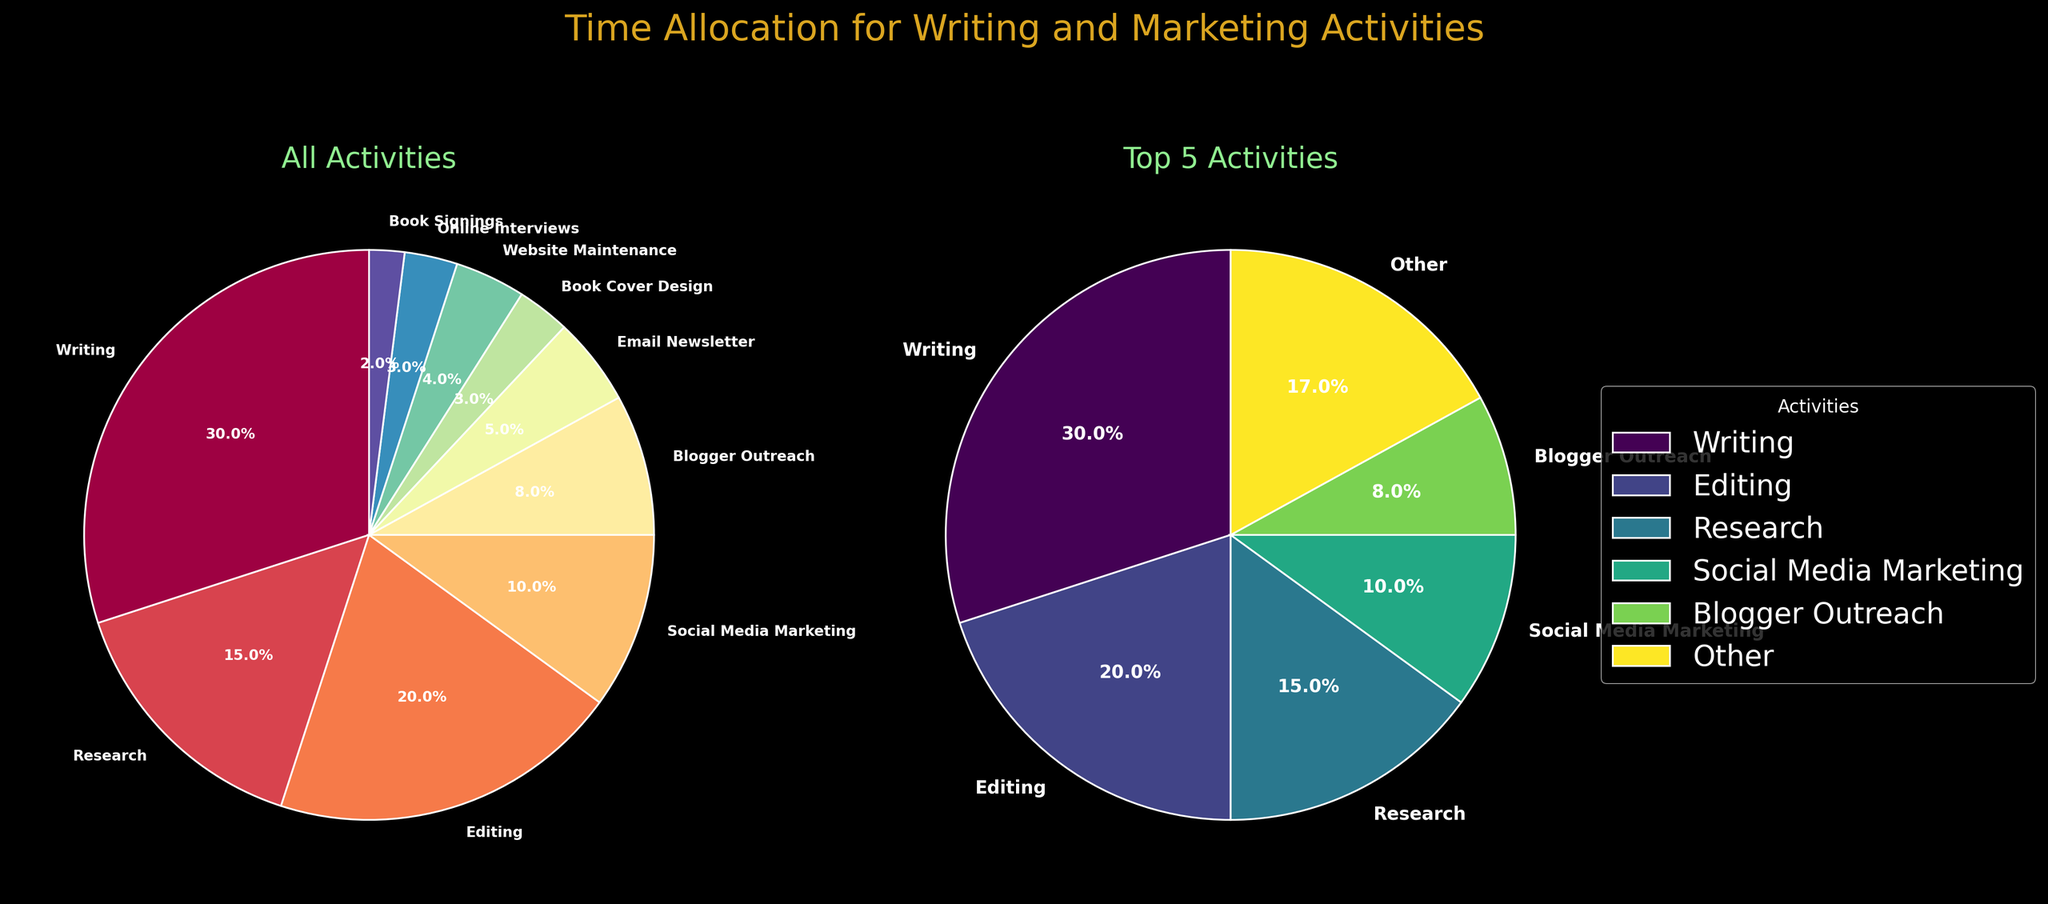What is the title of the figure? The title of the figure is displayed at the top and reads "Time Allocation for Writing and Marketing Activities."
Answer: Time Allocation for Writing and Marketing Activities Which activity takes up the largest portion of time in the "All Activities" pie chart? The largest portion can be identified by visually determining the largest wedge in the "All Activities" pie chart. It's labelled as "Writing".
Answer: Writing How many hours are allocated to "Research" and "Editing" combined? From the figure, "Research" is allocated 15 hours and "Editing" is 20 hours. By adding these (15 + 20), we get the combined total.
Answer: 35 hours What color scheme is used for the "All Activities" pie chart? The "All Activities" pie chart uses a spectrum of colors from the colormap 'Spectral', as indicated by the variety of colors used.
Answer: Spectral colormap Which activities are included in the "Top 5 Activities" pie chart? The "Top 5 Activities" pie chart lists the top 5 activities and includes a segment for "Other". The activities listed are: Writing, Research, Editing, Social Media Marketing, Blogger Outreach, and Other.
Answer: Writing, Research, Editing, Social Media Marketing, Blogger Outreach, Other What percentage of the total time is spent on "Social Media Marketing" in the "Top 5 Activities" pie chart? The "Top 5 Activities" pie chart shows each segment's percentage. The segment for "Social Media Marketing" is labeled with its percentage value, which is 10.8%.
Answer: 10.8% If you sum the hours allocated to "Book Cover Design," "Website Maintenance," "Online Interviews," and "Book Signings," what is the total? By adding the hours provided: Book Cover Design (3), Website Maintenance (4), Online Interviews (3), and Book Signings (2), the total is 3 + 4 + 3 + 2 = 12 hours.
Answer: 12 hours Which activity in the "All Activities" pie chart has the smallest allocated time, and how many hours is it? The smallest wedge in the "All Activities" pie chart, labelled with the least hours, is "Book Signings." This activity has 2 hours allocated to it.
Answer: Book Signings, 2 hours What is the total percentage of time spent on activities other than the "Top 5 Activities"? In the "Top 5 Activities" pie chart, the "Other" segment represents all activities outside of the top 5. This segment is labeled as 18.3%.
Answer: 18.3% How do the total hours compare between "Writing" and "Editing"? From the list of activities, "Writing" has 30 hours and "Editing" has 20 hours. "Writing" has 10 hours more than "Editing."
Answer: Writing has 10 more hours than Editing 